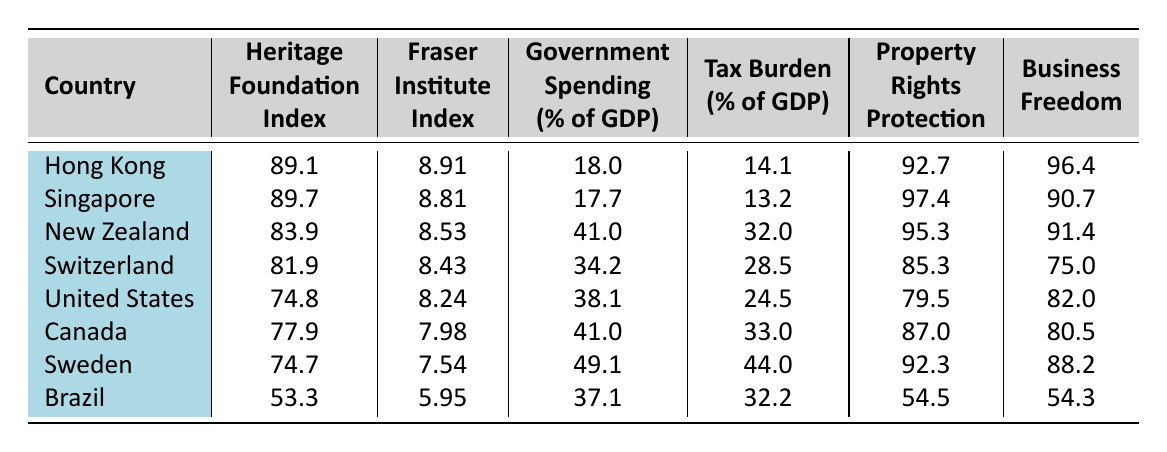What is the Heritage Foundation Index of Singapore? From the table, the Heritage Foundation Index for Singapore is listed clearly under its respective column. It states "89.7" for Singapore.
Answer: 89.7 Which country has the highest Business Freedom score? By searching through the Business Freedom column, I find that Hong Kong has the highest score of 96.4.
Answer: Hong Kong What is the average Tax Burden (%) for the countries listed? To find the average Tax Burden, first sum the Tax Burden values: (14.1 + 13.2 + 32.0 + 28.5 + 24.5 + 33.0 + 44.0 + 32.2) = 188.5. There are 8 countries total, so the average is 188.5 / 8 = 23.56.
Answer: 23.56 Is the Property Rights Protection in the United States greater than 80? Checking the Property Rights Protection column, the value for the United States is "79.5", which is less than 80.
Answer: No Which country has the smallest Heritage Foundation Index and what is its value? Looking for the smallest Heritage Foundation Index, I see that Brazil has an index of "53.3" listed, which is the lowest in the table.
Answer: Brazil, 53.3 What is the difference in Government Spending (% of GDP) between New Zealand and Sweden? The Government Spending for New Zealand is 41.0% and for Sweden is 49.1%. To find the difference, subtract: 49.1 - 41.0 = 8.1.
Answer: 8.1 Do all countries listed have a Tax Burden greater than 10%? Reviewing the Tax Burden column, I see all listed countries have values above 10%, with the lowest being 14.1%. Thus, the statement is true.
Answer: Yes Which country has the lowest Fraser Institute Index, and is it also a country with high government spending? The lowest Fraser Institute Index is for Brazil with a value of 5.95. Looking at the Government Spending column, Brazil’s government spending is 37.1%, which is relatively high compared to the others.
Answer: Brazil, yes 